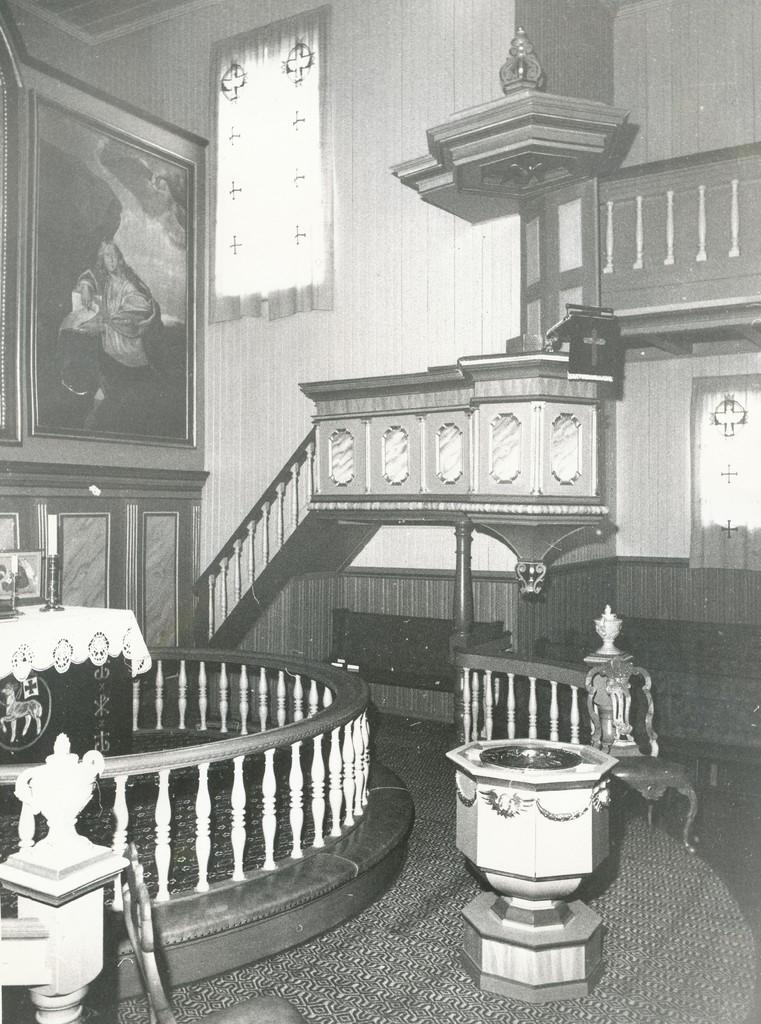What is the color scheme of the image? The image is black and white. What architectural feature can be seen in the image? There is a staircase in the image. What safety feature is present along the staircase? There are railings in the image. What type of artwork is visible in the image? There are paintings in the image. What type of furniture is present in the image? There are tables and chairs in the image. What other objects can be seen in the image? There are a few other objects in the image. What type of story is being told by the zebra in the image? There is no zebra present in the image, so no story can be told by a zebra. 